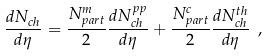Convert formula to latex. <formula><loc_0><loc_0><loc_500><loc_500>\frac { d N _ { c h } } { d \eta } = \frac { N _ { p a r t } ^ { m } } { 2 } \frac { d N _ { c h } ^ { p p } } { d \eta } + \frac { N _ { p a r t } ^ { c } } { 2 } \frac { d N _ { c h } ^ { t h } } { d \eta } \ ,</formula> 